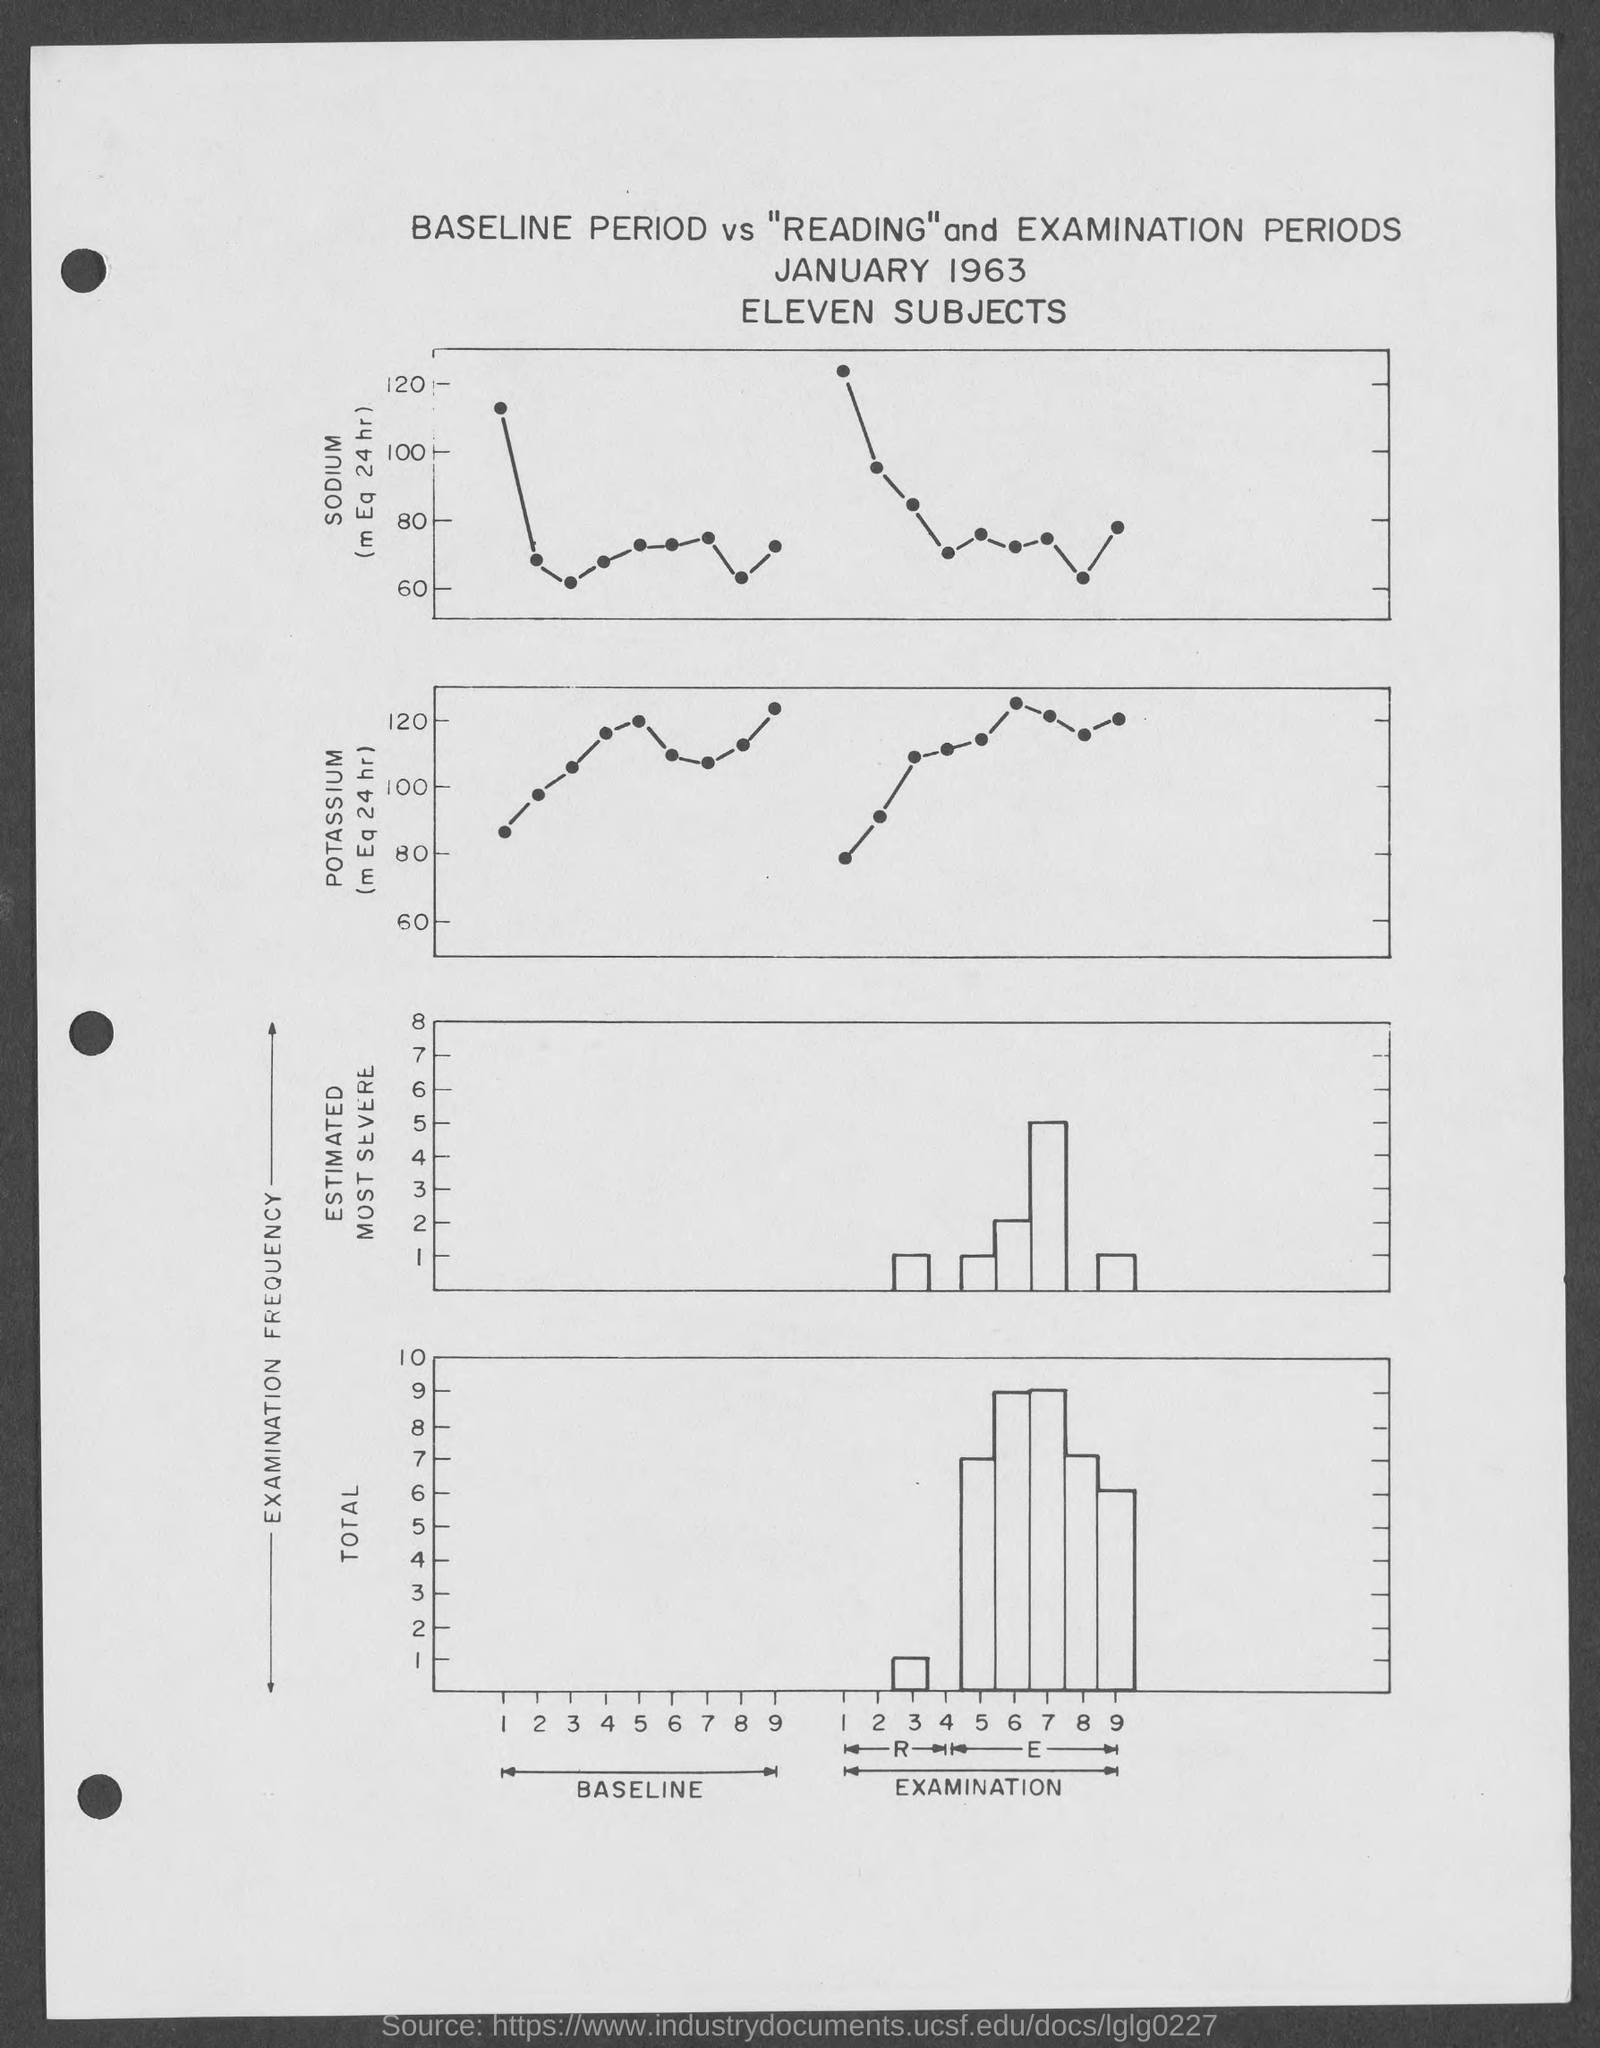Which month and year are given under the title of the page?
Keep it short and to the point. January 1963. Which chemical element is marked at the Y-axis of the top graph?
Make the answer very short. Sodium. Which chemical element is marked at the Y-axis of the second section of the graph?
Provide a short and direct response. Potassium. What is the maximum value given in the y-axis of the top section of the graph?
Provide a succinct answer. 120. What is the text written under "january 1963"?
Make the answer very short. Eleven subjects. What is the maximum total value of y-axis of the graph given at the bottom of the page?
Your answer should be very brief. 10. What is the top most title of the page?
Keep it short and to the point. Baseline period vs "reading" and examination periods. What does the first part of x-axis represent?
Your answer should be very brief. Baseline. 